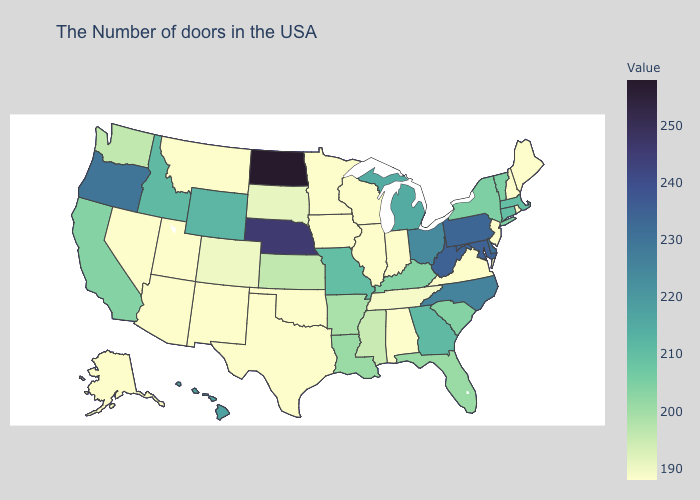Does California have the lowest value in the West?
Give a very brief answer. No. Is the legend a continuous bar?
Quick response, please. Yes. Among the states that border Louisiana , which have the lowest value?
Short answer required. Texas. Among the states that border Georgia , does Florida have the lowest value?
Give a very brief answer. No. Does Maryland have the highest value in the USA?
Quick response, please. No. Does Minnesota have a lower value than New York?
Answer briefly. Yes. Which states have the highest value in the USA?
Give a very brief answer. North Dakota. Does North Carolina have the highest value in the USA?
Be succinct. No. 